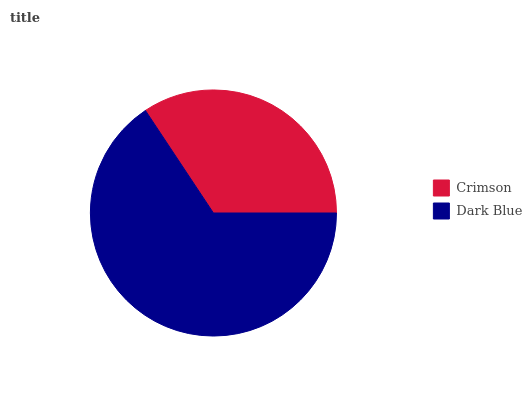Is Crimson the minimum?
Answer yes or no. Yes. Is Dark Blue the maximum?
Answer yes or no. Yes. Is Dark Blue the minimum?
Answer yes or no. No. Is Dark Blue greater than Crimson?
Answer yes or no. Yes. Is Crimson less than Dark Blue?
Answer yes or no. Yes. Is Crimson greater than Dark Blue?
Answer yes or no. No. Is Dark Blue less than Crimson?
Answer yes or no. No. Is Dark Blue the high median?
Answer yes or no. Yes. Is Crimson the low median?
Answer yes or no. Yes. Is Crimson the high median?
Answer yes or no. No. Is Dark Blue the low median?
Answer yes or no. No. 